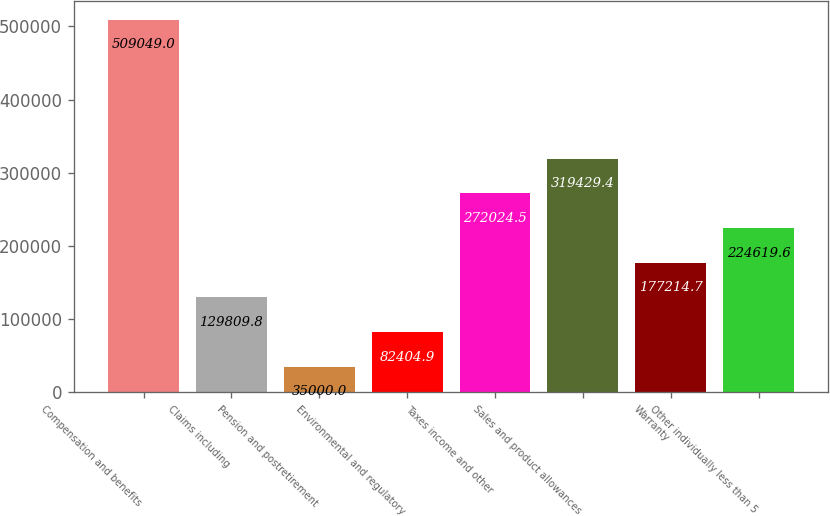Convert chart. <chart><loc_0><loc_0><loc_500><loc_500><bar_chart><fcel>Compensation and benefits<fcel>Claims including<fcel>Pension and postretirement<fcel>Environmental and regulatory<fcel>Taxes income and other<fcel>Sales and product allowances<fcel>Warranty<fcel>Other individually less than 5<nl><fcel>509049<fcel>129810<fcel>35000<fcel>82404.9<fcel>272024<fcel>319429<fcel>177215<fcel>224620<nl></chart> 